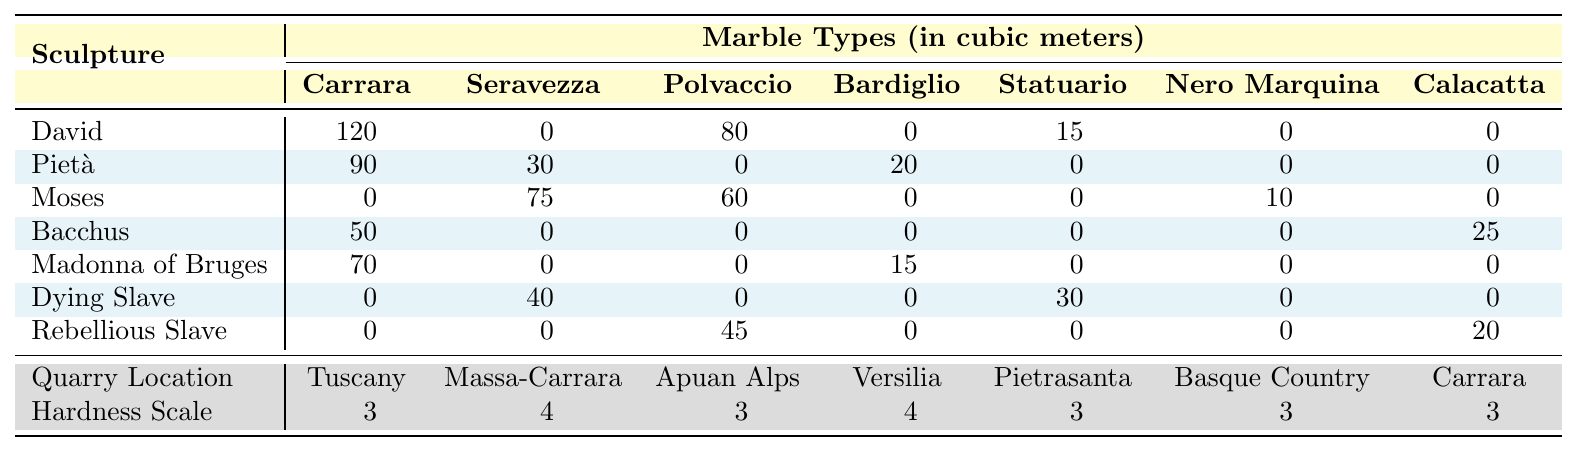What marble type was used for the most sculptures? The table lists the amount of marble used for each sculpture. By examining the total amounts for each marble type across all sculptures, we can see which type has the highest total usage. Carrara has the highest total: 120 (David) + 90 (Pietà) + 0 + 50 (Bacchus) + 70 (Madonna of Bruges) + 0 + 0 = 330.
Answer: Carrara Which sculpture used the most cubic meters of marble in total? To find the sculpture with the most marble used, we sum the cubic meters for each sculpture. For David: 120 + 0 + 80 + 0 + 15 + 0 + 0 = 215; Pietà: 90 + 30 + 0 + 20 + 0 + 0 + 0 = 140; Moses: 0 + 75 + 60 + 0 + 0 + 10 + 0 = 145; Bacchus: 50 + 0 + 0 + 0 + 0 + 0 + 25 = 75; Madonna of Bruges: 70 + 0 + 0 + 15 + 0 + 0 + 0 = 85; Dying Slave: 0 + 40 + 0 + 0 + 30 + 0 + 0 = 70; Rebellious Slave: 0 + 0 + 45 + 0 + 0 + 0 + 20 = 65. David has the highest total amount of 215 cubic meters.
Answer: David What is the total amount of Seravezza marble used in all sculptures? The amount of Seravezza marble for each sculpture is 0 (David), 30 (Pietà), 75 (Moses), 0 (Bacchus), 0 (Madonna of Bruges), 40 (Dying Slave), and 0 (Rebellious Slave). Summing these values gives 0 + 30 + 75 + 0 + 0 + 40 + 0 = 145 cubic meters.
Answer: 145 Which sculpture used Statuario marble and how much? Looking at the table, only the Dying Slave (30 cubic meters) and Bacchus (0 cubic meters) sculptures used Statuario marble. The Dying Slave used 30 cubic meters, while Bacchus did not use any.
Answer: Dying Slave, 30 cubic meters Is there any sculpture that used more than 50 cubic meters of Nero Marquina marble? Referring to the data for Nero Marquina, only Bacchus (25) and Rebellious Slave (20) marble usage is shown. Both are under 50 cubic meters, and thus, no sculpture exceeds 50 cubic meters of usage.
Answer: No What is the average amount of marble used for all sculptures? To find the average, we first sum the total marble used across all sculptures: 215 (David) + 140 (Pietà) + 145 (Moses) + 75 (Bacchus) + 85 (Madonna of Bruges) + 70 (Dying Slave) + 65 (Rebellious Slave) = 795. Then, we divide by the number of sculptures, which is 7: 795 / 7 = 113.57.
Answer: 113.57 What is the difference in total marble volume used between the David and the Madonna of Bruges? Calculating the totals, David used 215 cubic meters and Madonna of Bruges used 85 cubic meters. The difference is 215 - 85 = 130 cubic meters.
Answer: 130 Identify the marble type with the highest hardness rating and its corresponding sculpture use. In the hardness scale, Seravezza and Bardiglio are rated at 4. Seravezza is used in the Pietà (amount 30) and no sculptures use Bardiglio. Hence, the highest hardness rating comes from Seravezza, which is both usable and used in Pietà.
Answer: Seravezza, Pietà Which quarry location provides the highest hardness rated marble? Among the quarry locations, Massa-Carrara gives a hardness rating of 4. Since no other location exceeds this level, Masse-Carrara is the correct answer.
Answer: Massa-Carrara How many cubic meters of marble were used in total from the Apuan Alps? Referring to the table, the only sculpture that used marble from the Apuan Alps was Moses, which used 60 cubic meters.
Answer: 60 cubic meters 